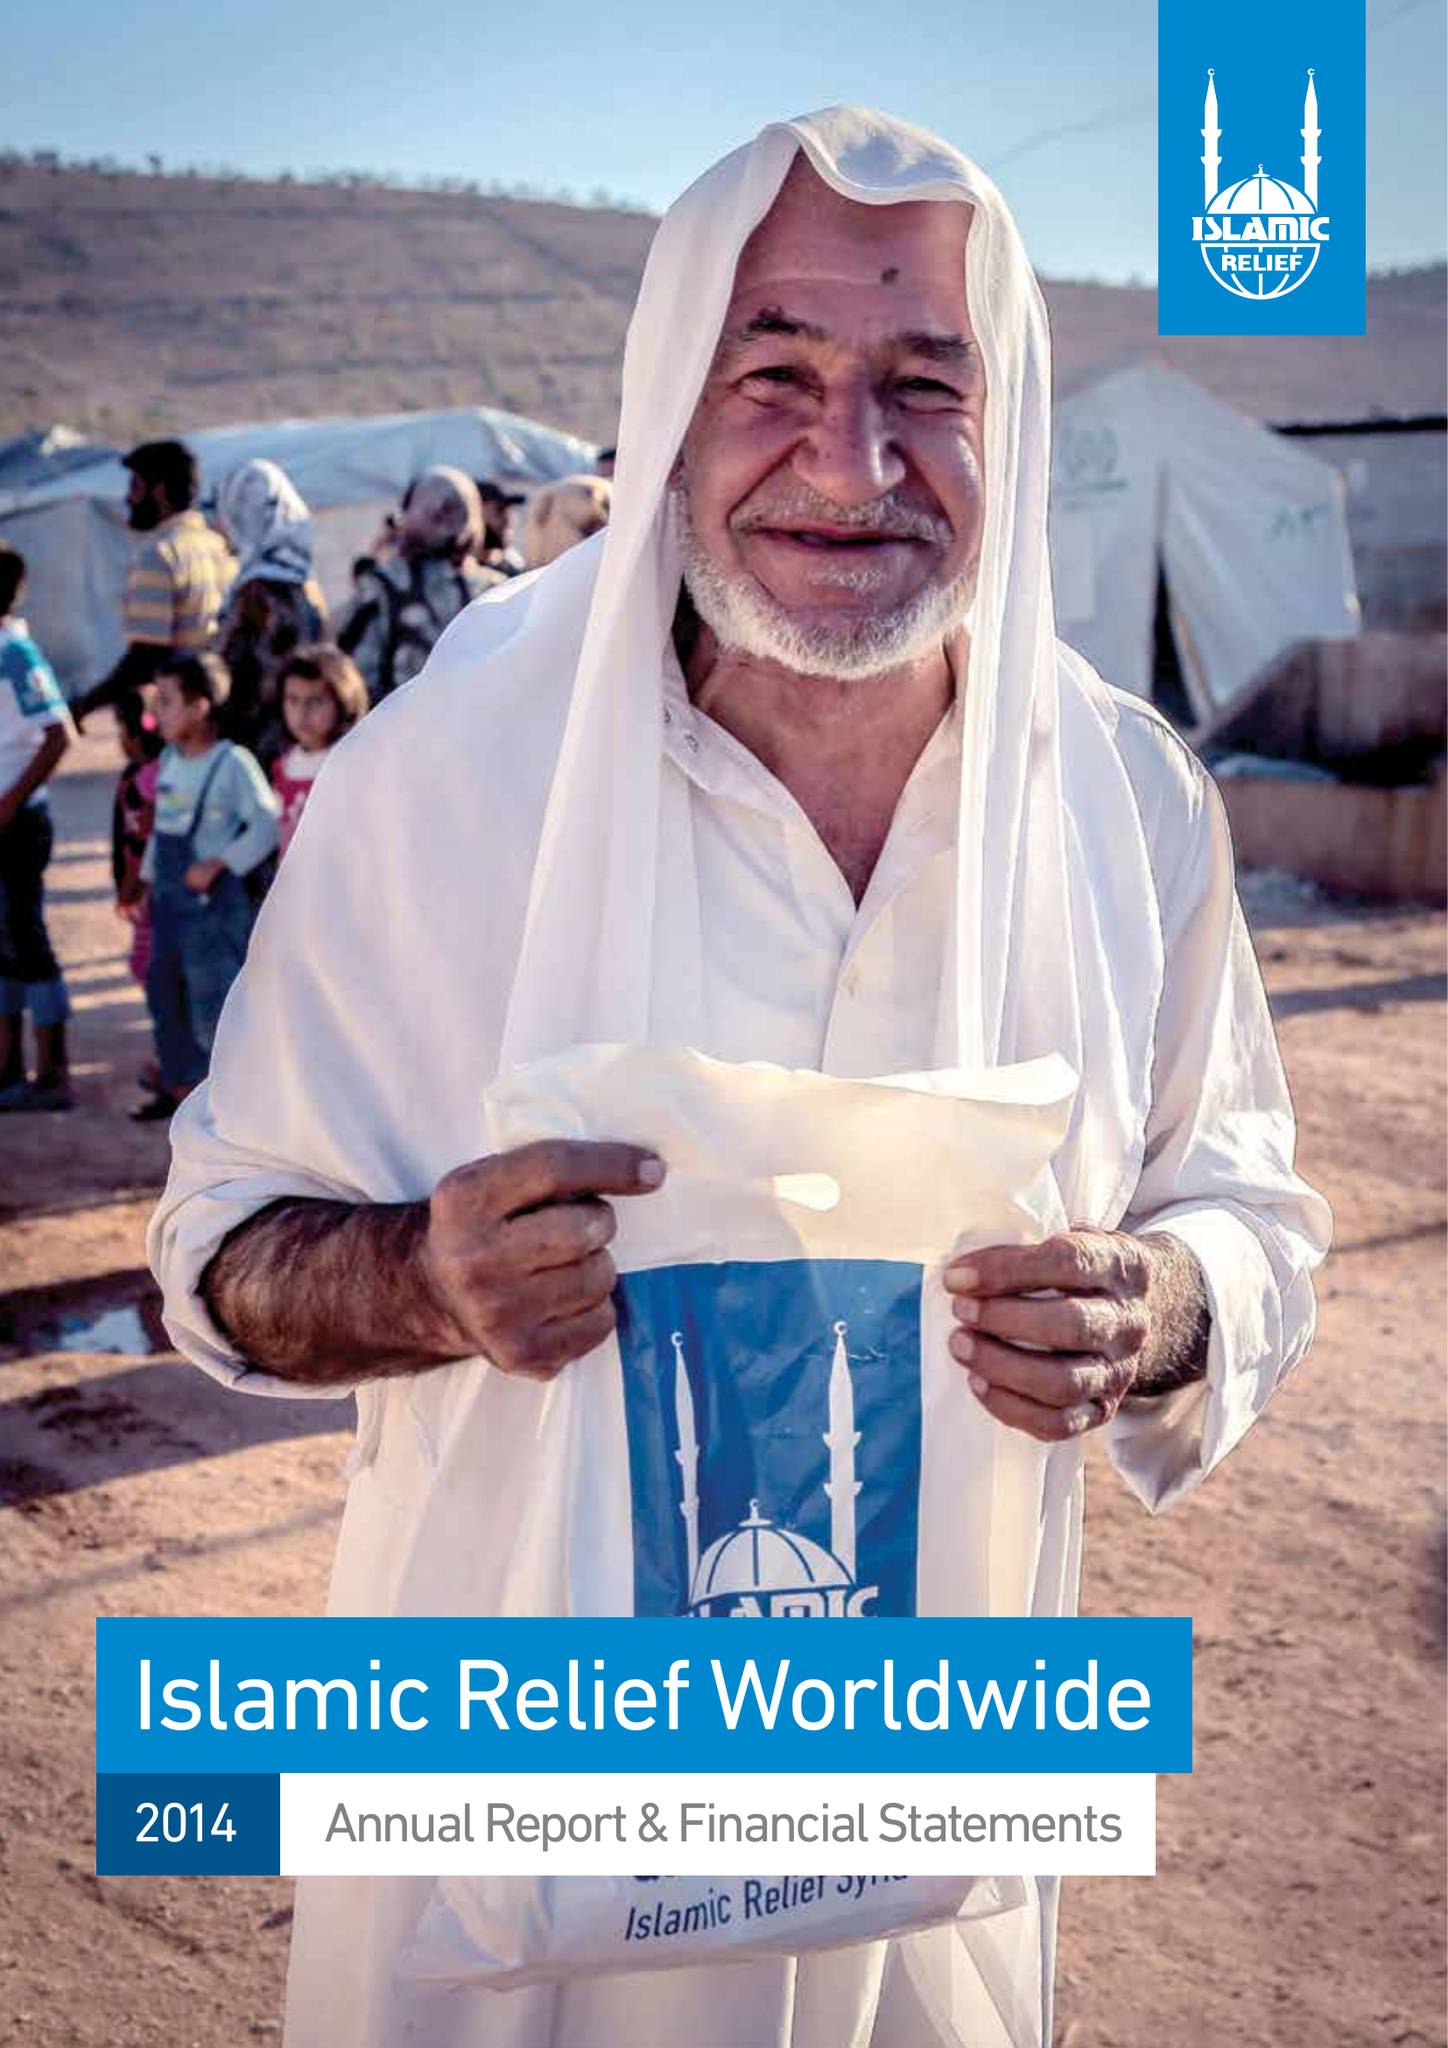What is the value for the income_annually_in_british_pounds?
Answer the question using a single word or phrase. 99142152.00 